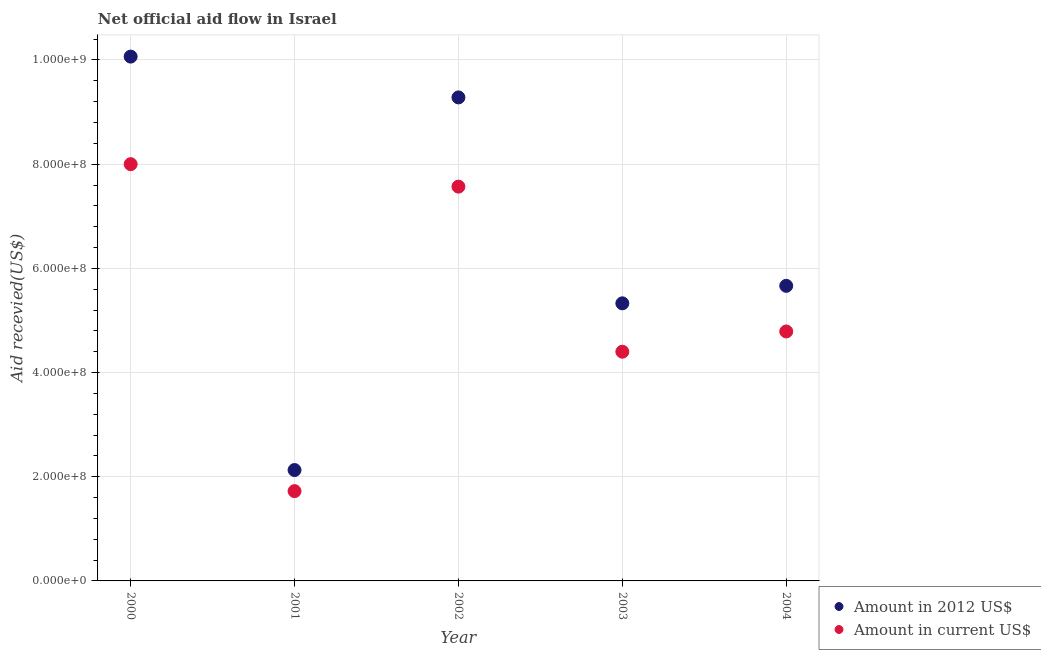How many different coloured dotlines are there?
Give a very brief answer. 2. Is the number of dotlines equal to the number of legend labels?
Your answer should be very brief. Yes. What is the amount of aid received(expressed in 2012 us$) in 2002?
Keep it short and to the point. 9.28e+08. Across all years, what is the maximum amount of aid received(expressed in us$)?
Keep it short and to the point. 8.00e+08. Across all years, what is the minimum amount of aid received(expressed in us$)?
Keep it short and to the point. 1.72e+08. In which year was the amount of aid received(expressed in 2012 us$) minimum?
Give a very brief answer. 2001. What is the total amount of aid received(expressed in us$) in the graph?
Ensure brevity in your answer.  2.65e+09. What is the difference between the amount of aid received(expressed in 2012 us$) in 2000 and that in 2003?
Your answer should be compact. 4.74e+08. What is the difference between the amount of aid received(expressed in 2012 us$) in 2002 and the amount of aid received(expressed in us$) in 2000?
Make the answer very short. 1.28e+08. What is the average amount of aid received(expressed in 2012 us$) per year?
Your response must be concise. 6.49e+08. In the year 2004, what is the difference between the amount of aid received(expressed in 2012 us$) and amount of aid received(expressed in us$)?
Give a very brief answer. 8.76e+07. What is the ratio of the amount of aid received(expressed in us$) in 2000 to that in 2003?
Your answer should be very brief. 1.82. Is the amount of aid received(expressed in us$) in 2002 less than that in 2004?
Your answer should be very brief. No. What is the difference between the highest and the second highest amount of aid received(expressed in us$)?
Keep it short and to the point. 4.31e+07. What is the difference between the highest and the lowest amount of aid received(expressed in us$)?
Provide a succinct answer. 6.28e+08. Does the amount of aid received(expressed in us$) monotonically increase over the years?
Your response must be concise. No. Is the amount of aid received(expressed in us$) strictly greater than the amount of aid received(expressed in 2012 us$) over the years?
Give a very brief answer. No. Is the amount of aid received(expressed in us$) strictly less than the amount of aid received(expressed in 2012 us$) over the years?
Give a very brief answer. Yes. What is the difference between two consecutive major ticks on the Y-axis?
Provide a short and direct response. 2.00e+08. Are the values on the major ticks of Y-axis written in scientific E-notation?
Give a very brief answer. Yes. How are the legend labels stacked?
Your response must be concise. Vertical. What is the title of the graph?
Your answer should be compact. Net official aid flow in Israel. What is the label or title of the Y-axis?
Offer a very short reply. Aid recevied(US$). What is the Aid recevied(US$) of Amount in 2012 US$ in 2000?
Give a very brief answer. 1.01e+09. What is the Aid recevied(US$) in Amount in current US$ in 2000?
Your answer should be very brief. 8.00e+08. What is the Aid recevied(US$) of Amount in 2012 US$ in 2001?
Your answer should be very brief. 2.13e+08. What is the Aid recevied(US$) of Amount in current US$ in 2001?
Provide a succinct answer. 1.72e+08. What is the Aid recevied(US$) in Amount in 2012 US$ in 2002?
Your answer should be compact. 9.28e+08. What is the Aid recevied(US$) in Amount in current US$ in 2002?
Give a very brief answer. 7.57e+08. What is the Aid recevied(US$) of Amount in 2012 US$ in 2003?
Give a very brief answer. 5.33e+08. What is the Aid recevied(US$) of Amount in current US$ in 2003?
Provide a short and direct response. 4.40e+08. What is the Aid recevied(US$) in Amount in 2012 US$ in 2004?
Keep it short and to the point. 5.66e+08. What is the Aid recevied(US$) of Amount in current US$ in 2004?
Your response must be concise. 4.79e+08. Across all years, what is the maximum Aid recevied(US$) in Amount in 2012 US$?
Keep it short and to the point. 1.01e+09. Across all years, what is the maximum Aid recevied(US$) of Amount in current US$?
Ensure brevity in your answer.  8.00e+08. Across all years, what is the minimum Aid recevied(US$) in Amount in 2012 US$?
Provide a short and direct response. 2.13e+08. Across all years, what is the minimum Aid recevied(US$) in Amount in current US$?
Your answer should be very brief. 1.72e+08. What is the total Aid recevied(US$) in Amount in 2012 US$ in the graph?
Your answer should be very brief. 3.25e+09. What is the total Aid recevied(US$) in Amount in current US$ in the graph?
Your answer should be very brief. 2.65e+09. What is the difference between the Aid recevied(US$) of Amount in 2012 US$ in 2000 and that in 2001?
Make the answer very short. 7.94e+08. What is the difference between the Aid recevied(US$) of Amount in current US$ in 2000 and that in 2001?
Keep it short and to the point. 6.28e+08. What is the difference between the Aid recevied(US$) in Amount in 2012 US$ in 2000 and that in 2002?
Provide a succinct answer. 7.83e+07. What is the difference between the Aid recevied(US$) in Amount in current US$ in 2000 and that in 2002?
Your response must be concise. 4.31e+07. What is the difference between the Aid recevied(US$) in Amount in 2012 US$ in 2000 and that in 2003?
Your response must be concise. 4.74e+08. What is the difference between the Aid recevied(US$) in Amount in current US$ in 2000 and that in 2003?
Offer a terse response. 3.60e+08. What is the difference between the Aid recevied(US$) in Amount in 2012 US$ in 2000 and that in 2004?
Give a very brief answer. 4.40e+08. What is the difference between the Aid recevied(US$) of Amount in current US$ in 2000 and that in 2004?
Your answer should be very brief. 3.21e+08. What is the difference between the Aid recevied(US$) of Amount in 2012 US$ in 2001 and that in 2002?
Provide a short and direct response. -7.15e+08. What is the difference between the Aid recevied(US$) in Amount in current US$ in 2001 and that in 2002?
Make the answer very short. -5.85e+08. What is the difference between the Aid recevied(US$) of Amount in 2012 US$ in 2001 and that in 2003?
Offer a very short reply. -3.20e+08. What is the difference between the Aid recevied(US$) in Amount in current US$ in 2001 and that in 2003?
Provide a succinct answer. -2.68e+08. What is the difference between the Aid recevied(US$) in Amount in 2012 US$ in 2001 and that in 2004?
Give a very brief answer. -3.54e+08. What is the difference between the Aid recevied(US$) in Amount in current US$ in 2001 and that in 2004?
Provide a short and direct response. -3.06e+08. What is the difference between the Aid recevied(US$) of Amount in 2012 US$ in 2002 and that in 2003?
Your answer should be very brief. 3.95e+08. What is the difference between the Aid recevied(US$) in Amount in current US$ in 2002 and that in 2003?
Offer a very short reply. 3.17e+08. What is the difference between the Aid recevied(US$) in Amount in 2012 US$ in 2002 and that in 2004?
Keep it short and to the point. 3.62e+08. What is the difference between the Aid recevied(US$) in Amount in current US$ in 2002 and that in 2004?
Ensure brevity in your answer.  2.78e+08. What is the difference between the Aid recevied(US$) in Amount in 2012 US$ in 2003 and that in 2004?
Offer a very short reply. -3.36e+07. What is the difference between the Aid recevied(US$) of Amount in current US$ in 2003 and that in 2004?
Provide a succinct answer. -3.89e+07. What is the difference between the Aid recevied(US$) of Amount in 2012 US$ in 2000 and the Aid recevied(US$) of Amount in current US$ in 2001?
Your answer should be very brief. 8.34e+08. What is the difference between the Aid recevied(US$) in Amount in 2012 US$ in 2000 and the Aid recevied(US$) in Amount in current US$ in 2002?
Ensure brevity in your answer.  2.50e+08. What is the difference between the Aid recevied(US$) of Amount in 2012 US$ in 2000 and the Aid recevied(US$) of Amount in current US$ in 2003?
Keep it short and to the point. 5.66e+08. What is the difference between the Aid recevied(US$) in Amount in 2012 US$ in 2000 and the Aid recevied(US$) in Amount in current US$ in 2004?
Your response must be concise. 5.28e+08. What is the difference between the Aid recevied(US$) in Amount in 2012 US$ in 2001 and the Aid recevied(US$) in Amount in current US$ in 2002?
Your answer should be compact. -5.44e+08. What is the difference between the Aid recevied(US$) in Amount in 2012 US$ in 2001 and the Aid recevied(US$) in Amount in current US$ in 2003?
Your answer should be compact. -2.27e+08. What is the difference between the Aid recevied(US$) of Amount in 2012 US$ in 2001 and the Aid recevied(US$) of Amount in current US$ in 2004?
Ensure brevity in your answer.  -2.66e+08. What is the difference between the Aid recevied(US$) of Amount in 2012 US$ in 2002 and the Aid recevied(US$) of Amount in current US$ in 2003?
Provide a short and direct response. 4.88e+08. What is the difference between the Aid recevied(US$) in Amount in 2012 US$ in 2002 and the Aid recevied(US$) in Amount in current US$ in 2004?
Your answer should be very brief. 4.49e+08. What is the difference between the Aid recevied(US$) in Amount in 2012 US$ in 2003 and the Aid recevied(US$) in Amount in current US$ in 2004?
Keep it short and to the point. 5.40e+07. What is the average Aid recevied(US$) of Amount in 2012 US$ per year?
Provide a succinct answer. 6.49e+08. What is the average Aid recevied(US$) in Amount in current US$ per year?
Keep it short and to the point. 5.30e+08. In the year 2000, what is the difference between the Aid recevied(US$) of Amount in 2012 US$ and Aid recevied(US$) of Amount in current US$?
Offer a terse response. 2.06e+08. In the year 2001, what is the difference between the Aid recevied(US$) in Amount in 2012 US$ and Aid recevied(US$) in Amount in current US$?
Ensure brevity in your answer.  4.05e+07. In the year 2002, what is the difference between the Aid recevied(US$) in Amount in 2012 US$ and Aid recevied(US$) in Amount in current US$?
Your answer should be compact. 1.71e+08. In the year 2003, what is the difference between the Aid recevied(US$) of Amount in 2012 US$ and Aid recevied(US$) of Amount in current US$?
Offer a terse response. 9.29e+07. In the year 2004, what is the difference between the Aid recevied(US$) in Amount in 2012 US$ and Aid recevied(US$) in Amount in current US$?
Your answer should be very brief. 8.76e+07. What is the ratio of the Aid recevied(US$) of Amount in 2012 US$ in 2000 to that in 2001?
Provide a short and direct response. 4.73. What is the ratio of the Aid recevied(US$) of Amount in current US$ in 2000 to that in 2001?
Make the answer very short. 4.64. What is the ratio of the Aid recevied(US$) of Amount in 2012 US$ in 2000 to that in 2002?
Your answer should be very brief. 1.08. What is the ratio of the Aid recevied(US$) in Amount in current US$ in 2000 to that in 2002?
Provide a short and direct response. 1.06. What is the ratio of the Aid recevied(US$) in Amount in 2012 US$ in 2000 to that in 2003?
Ensure brevity in your answer.  1.89. What is the ratio of the Aid recevied(US$) in Amount in current US$ in 2000 to that in 2003?
Offer a terse response. 1.82. What is the ratio of the Aid recevied(US$) of Amount in 2012 US$ in 2000 to that in 2004?
Provide a succinct answer. 1.78. What is the ratio of the Aid recevied(US$) of Amount in current US$ in 2000 to that in 2004?
Your answer should be very brief. 1.67. What is the ratio of the Aid recevied(US$) in Amount in 2012 US$ in 2001 to that in 2002?
Your answer should be compact. 0.23. What is the ratio of the Aid recevied(US$) of Amount in current US$ in 2001 to that in 2002?
Your response must be concise. 0.23. What is the ratio of the Aid recevied(US$) in Amount in 2012 US$ in 2001 to that in 2003?
Give a very brief answer. 0.4. What is the ratio of the Aid recevied(US$) in Amount in current US$ in 2001 to that in 2003?
Offer a terse response. 0.39. What is the ratio of the Aid recevied(US$) in Amount in 2012 US$ in 2001 to that in 2004?
Your response must be concise. 0.38. What is the ratio of the Aid recevied(US$) of Amount in current US$ in 2001 to that in 2004?
Ensure brevity in your answer.  0.36. What is the ratio of the Aid recevied(US$) of Amount in 2012 US$ in 2002 to that in 2003?
Keep it short and to the point. 1.74. What is the ratio of the Aid recevied(US$) in Amount in current US$ in 2002 to that in 2003?
Your response must be concise. 1.72. What is the ratio of the Aid recevied(US$) of Amount in 2012 US$ in 2002 to that in 2004?
Ensure brevity in your answer.  1.64. What is the ratio of the Aid recevied(US$) in Amount in current US$ in 2002 to that in 2004?
Your answer should be very brief. 1.58. What is the ratio of the Aid recevied(US$) in Amount in 2012 US$ in 2003 to that in 2004?
Give a very brief answer. 0.94. What is the ratio of the Aid recevied(US$) in Amount in current US$ in 2003 to that in 2004?
Your answer should be compact. 0.92. What is the difference between the highest and the second highest Aid recevied(US$) of Amount in 2012 US$?
Make the answer very short. 7.83e+07. What is the difference between the highest and the second highest Aid recevied(US$) in Amount in current US$?
Offer a terse response. 4.31e+07. What is the difference between the highest and the lowest Aid recevied(US$) in Amount in 2012 US$?
Ensure brevity in your answer.  7.94e+08. What is the difference between the highest and the lowest Aid recevied(US$) of Amount in current US$?
Provide a succinct answer. 6.28e+08. 